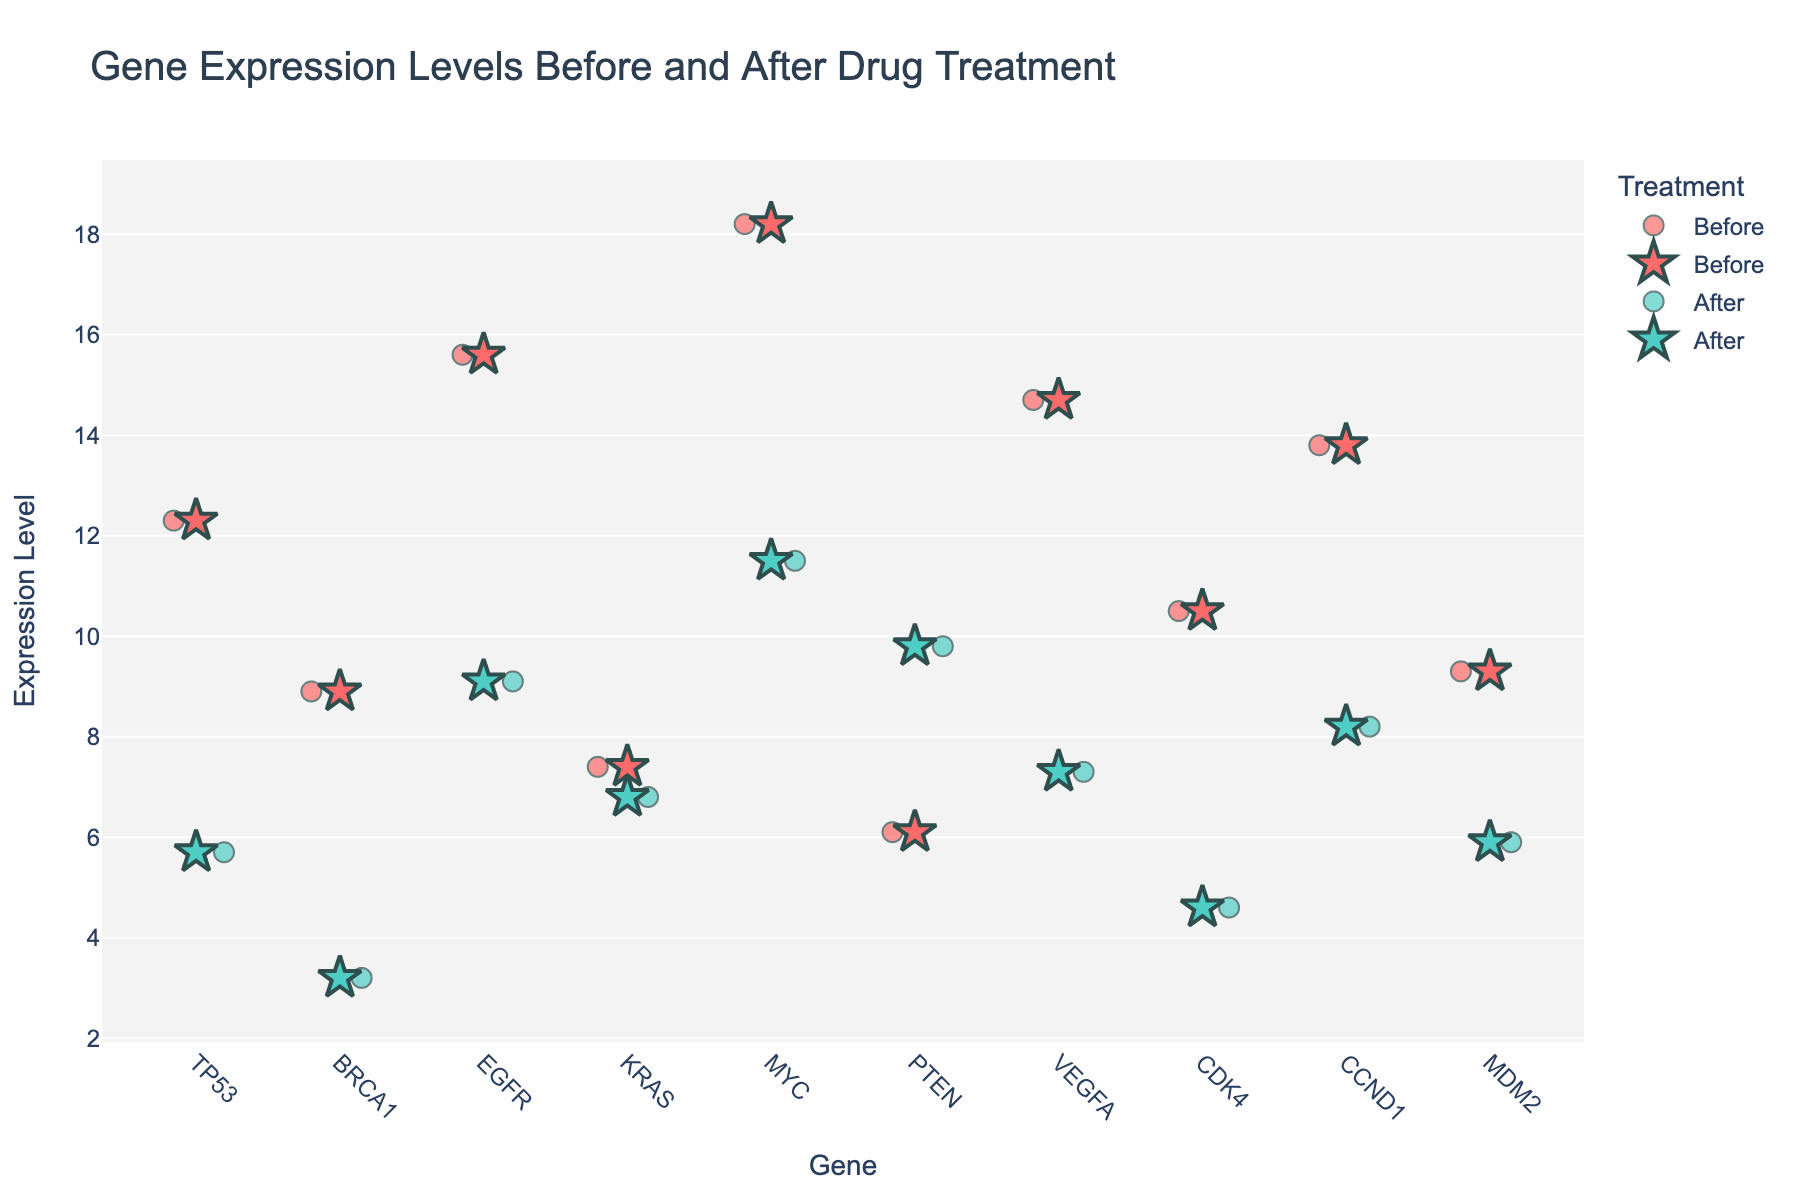what is the title of the figure? Look at the top of the figure to identify the title provided in the plot.
Answer: Gene Expression Levels Before and After Drug Treatment what are the two treatments compared in the figure? Identify the two categories of the 'Treatment' variable, typically distinguished by different colors.
Answer: Before and After how many genes are displayed on the x-axis? Count the unique gene labels along the x-axis.
Answer: 10 what color represents the 'After' treatment data points? Examine the legend or the color of the 'After' data points in the figure.
Answer: Teal (around #4ECDC4) which gene shows an increase in expression level after drug treatment? Compare the expression levels of each gene before and after treatment.
Answer: PTEN which gene exhibits the highest expression level before treatment? Identify the highest data point on the 'Expression Level' axis for the "Before" treatment.
Answer: MYC how does the expression level of EGFR change after treatment? Locate the expression levels for EGFR before and after treatment and compute the difference.
Answer: It decreases which gene has the smallest change in expression level after treatment? Compare the absolute differences in expression levels before and after treatment for each gene and identify the smallest.
Answer: KRAS are the expression levels generally higher or lower after treatment across genes? Evaluate the overall trend in expression levels from 'Before' to 'After' treatment across genes.
Answer: Generally lower 